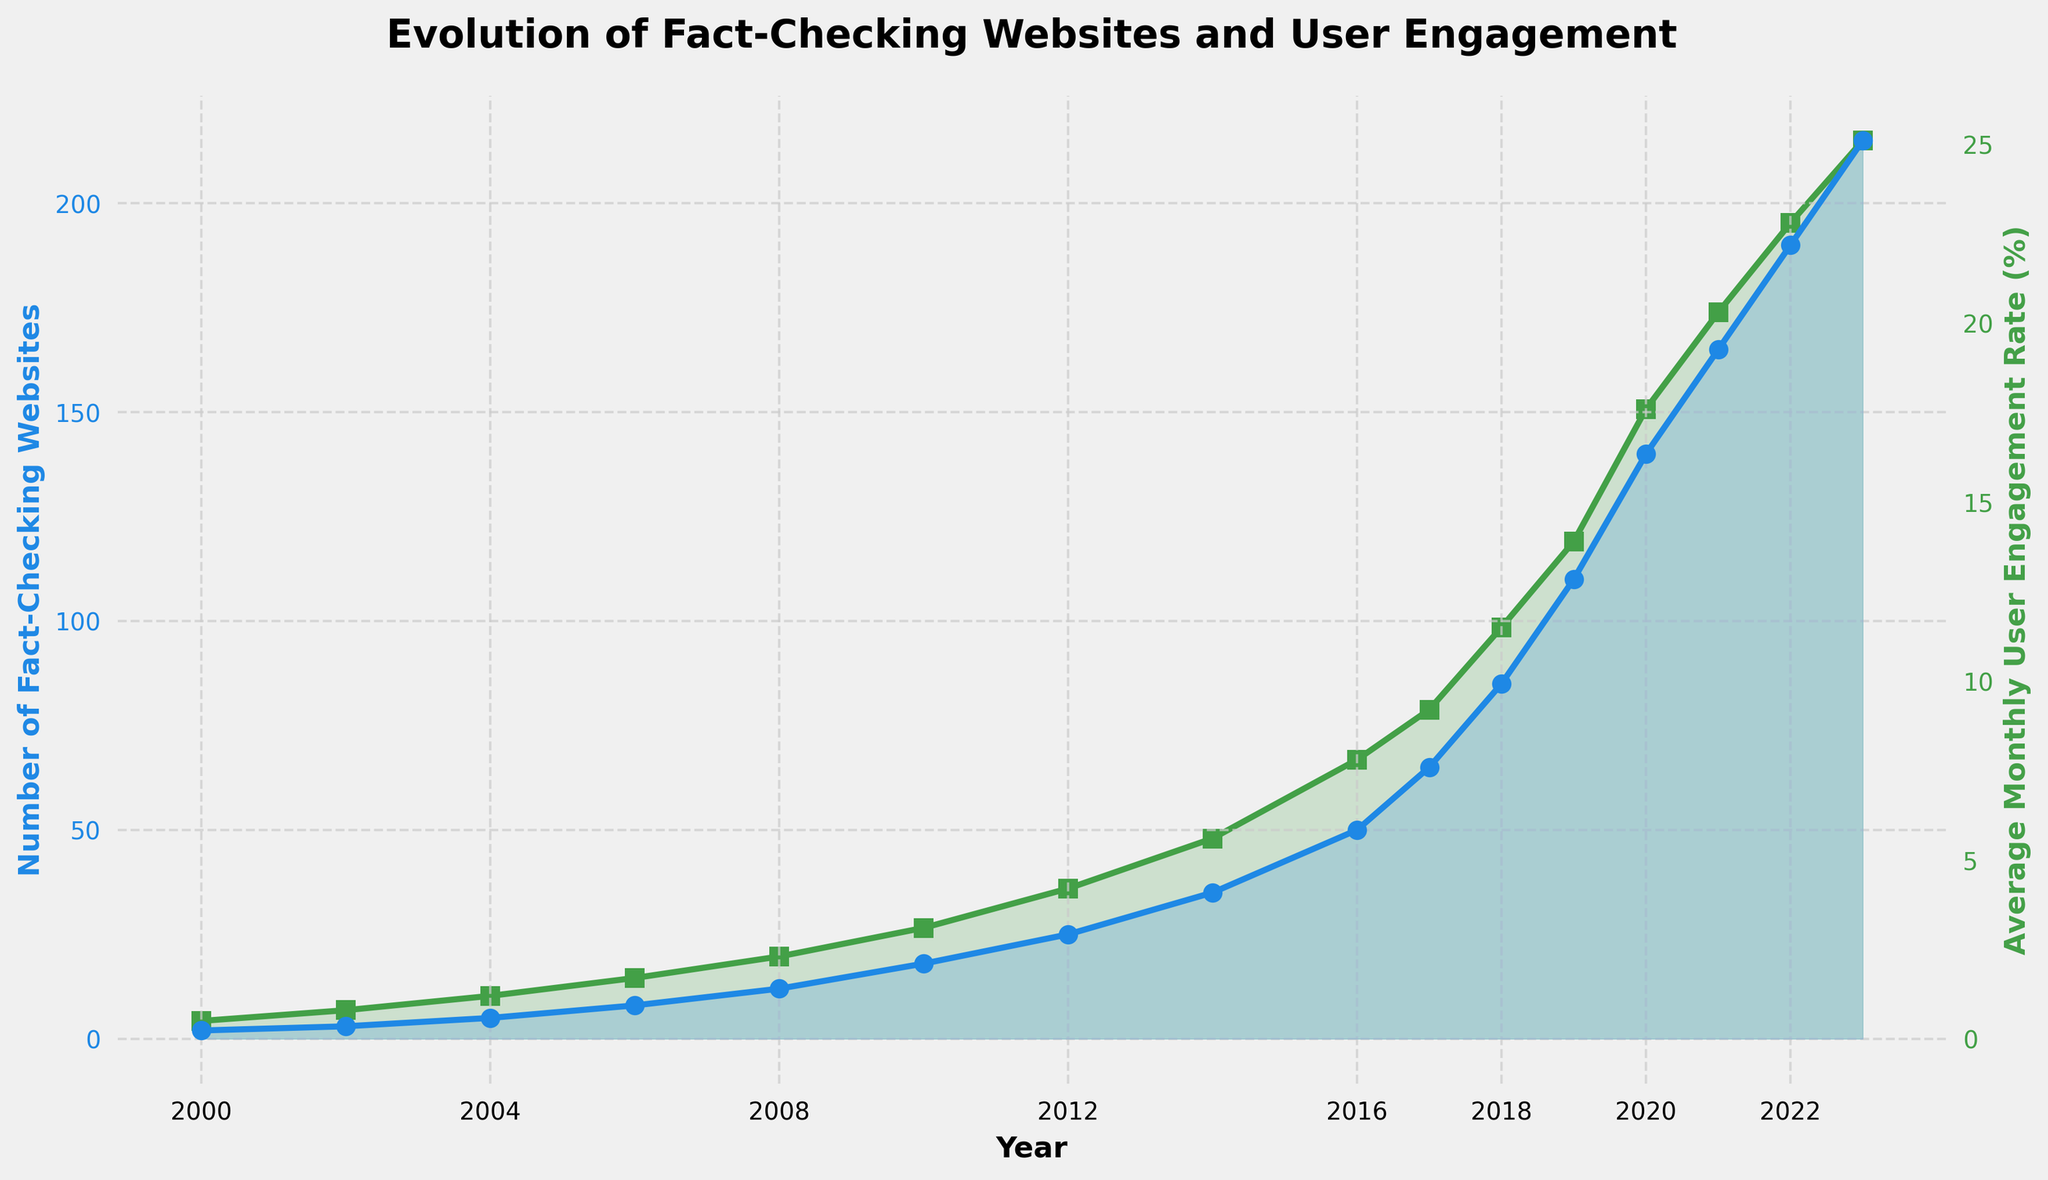What is the number of fact-checking websites in 2010 and the average monthly user engagement rate in that year? Look at the data points for the year 2010 on the figure. You'll find that the number of fact-checking websites is plotted in blue and the average monthly user engagement rate is plotted in green.
Answer: 18, 3.1% How did the number of fact-checking websites change between 2012 and 2016? Observe the blue line marking the number of fact-checking websites between 2012 and 2016. In 2012, there are 25 websites, and by 2016, there are 50. The change is 50 - 25.
Answer: Increased by 25 Which year saw the highest average monthly user engagement rate, and what was it? Check the green line representing the average monthly user engagement rate for each year. The highest point is in 2023 with a value of 25.1%.
Answer: 2023, 25.1% In which year did the number of fact-checking websites first exceed 100? Follow the blue line indicating the number of fact-checking websites. Locate the year where the count first crosses the 100 mark. In 2019, it reached 110.
Answer: 2019 What was the growth in the average monthly user engagement rate from 2000 to 2023? Find the green points for the years 2000 and 2023. Subtract the value in 2000 from the value in 2023: 25.1 - 0.5 = 24.6.
Answer: Increased by 24.6% Compare the average monthly user engagement rates in 2012 and 2014. Which year had a higher rate, and by how much? Check the green line to find values for 2012 and 2014. In 2012, the rate is 4.2%, and in 2014, it's 5.6%. The difference is 5.6 - 4.2.
Answer: 2014, by 1.4% What is the trend in the number of fact-checking websites from 2010 to 2023? Examine the slope of the blue line from 2010 to 2023. The line is consistently increasing, reflecting a steady rise in the number of websites.
Answer: Increasing Calculate the total increase in the number of fact-checking websites from 2000 to 2023. The initial and final values are 2 (in 2000) and 215 (in 2023). The total increase is 215 - 2.
Answer: Increased by 213 What is the relationship between the number of fact-checking websites and the average monthly user engagement rate? Both the blue and green lines are rising over time, indicating a positive correlation where increases in one are associated with increases in the other.
Answer: Positive correlation 